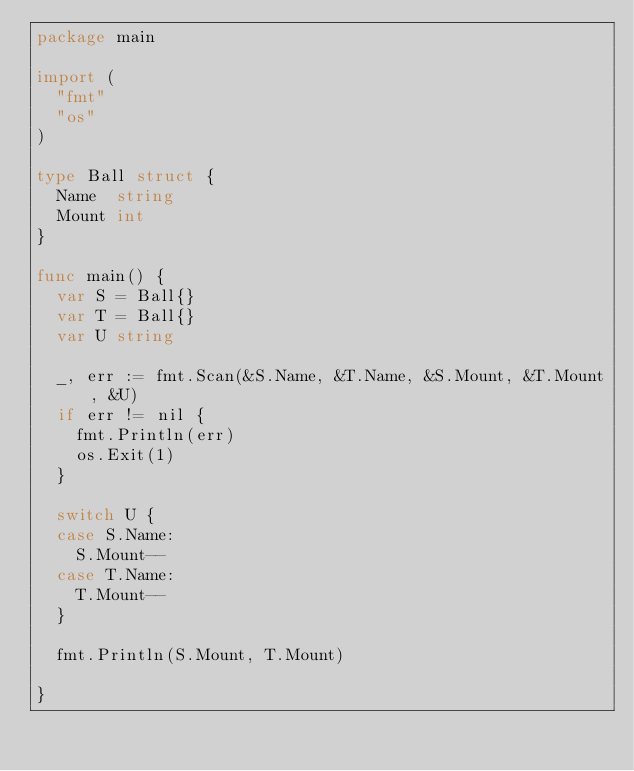Convert code to text. <code><loc_0><loc_0><loc_500><loc_500><_Go_>package main

import (
	"fmt"
	"os"
)

type Ball struct {
	Name  string
	Mount int
}

func main() {
	var S = Ball{}
	var T = Ball{}
	var U string

	_, err := fmt.Scan(&S.Name, &T.Name, &S.Mount, &T.Mount, &U)
	if err != nil {
		fmt.Println(err)
		os.Exit(1)
	}

	switch U {
	case S.Name:
		S.Mount--
	case T.Name:
		T.Mount--
	}

	fmt.Println(S.Mount, T.Mount)

}
</code> 